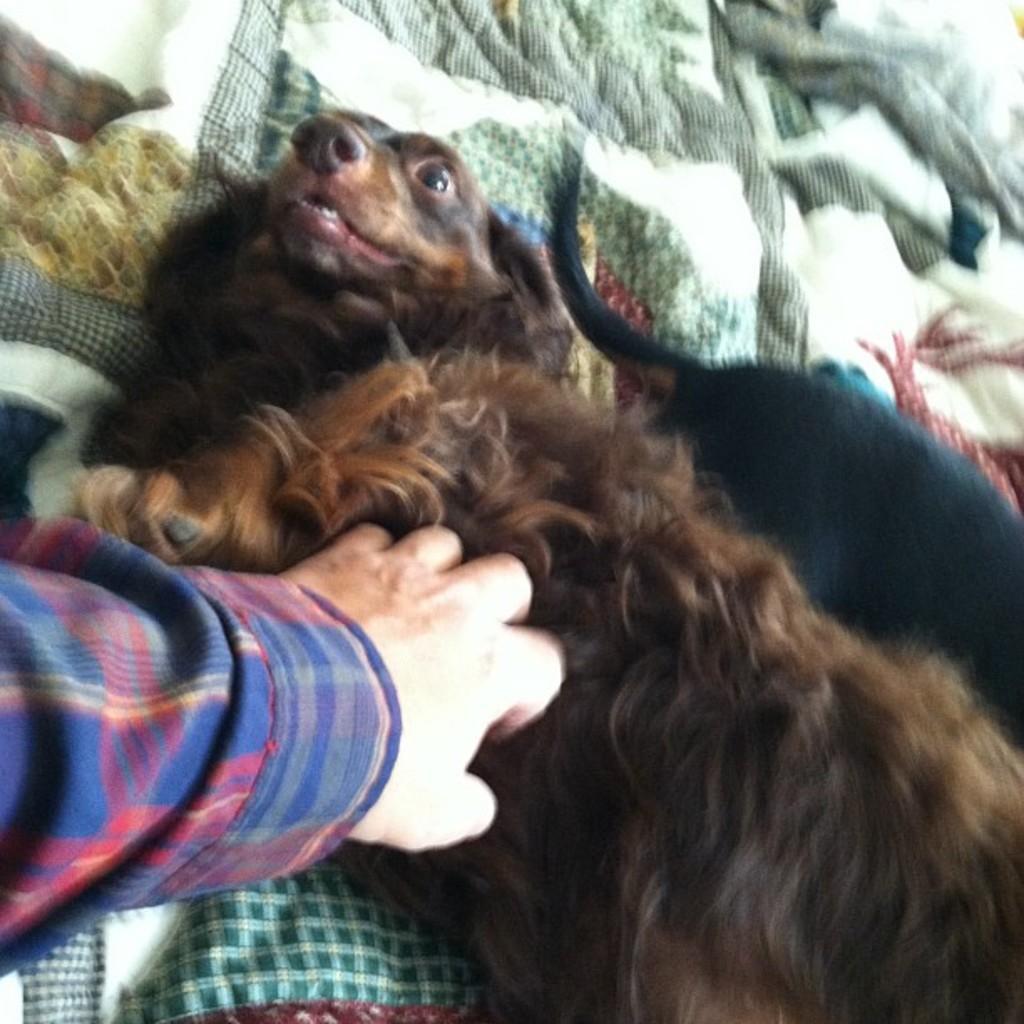Could you give a brief overview of what you see in this image? In this image we can see the dogs lying on a blanket. We can also see the hand of a person on a dog. 